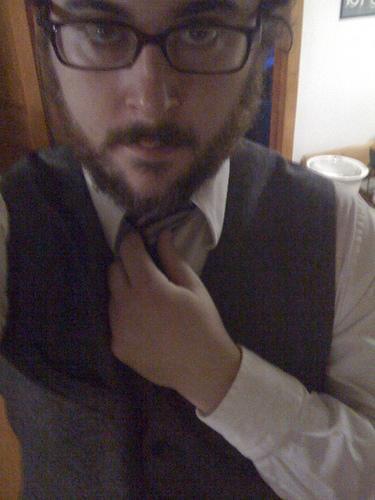How many glass bottles are on the ledge behind the stove?
Give a very brief answer. 0. 